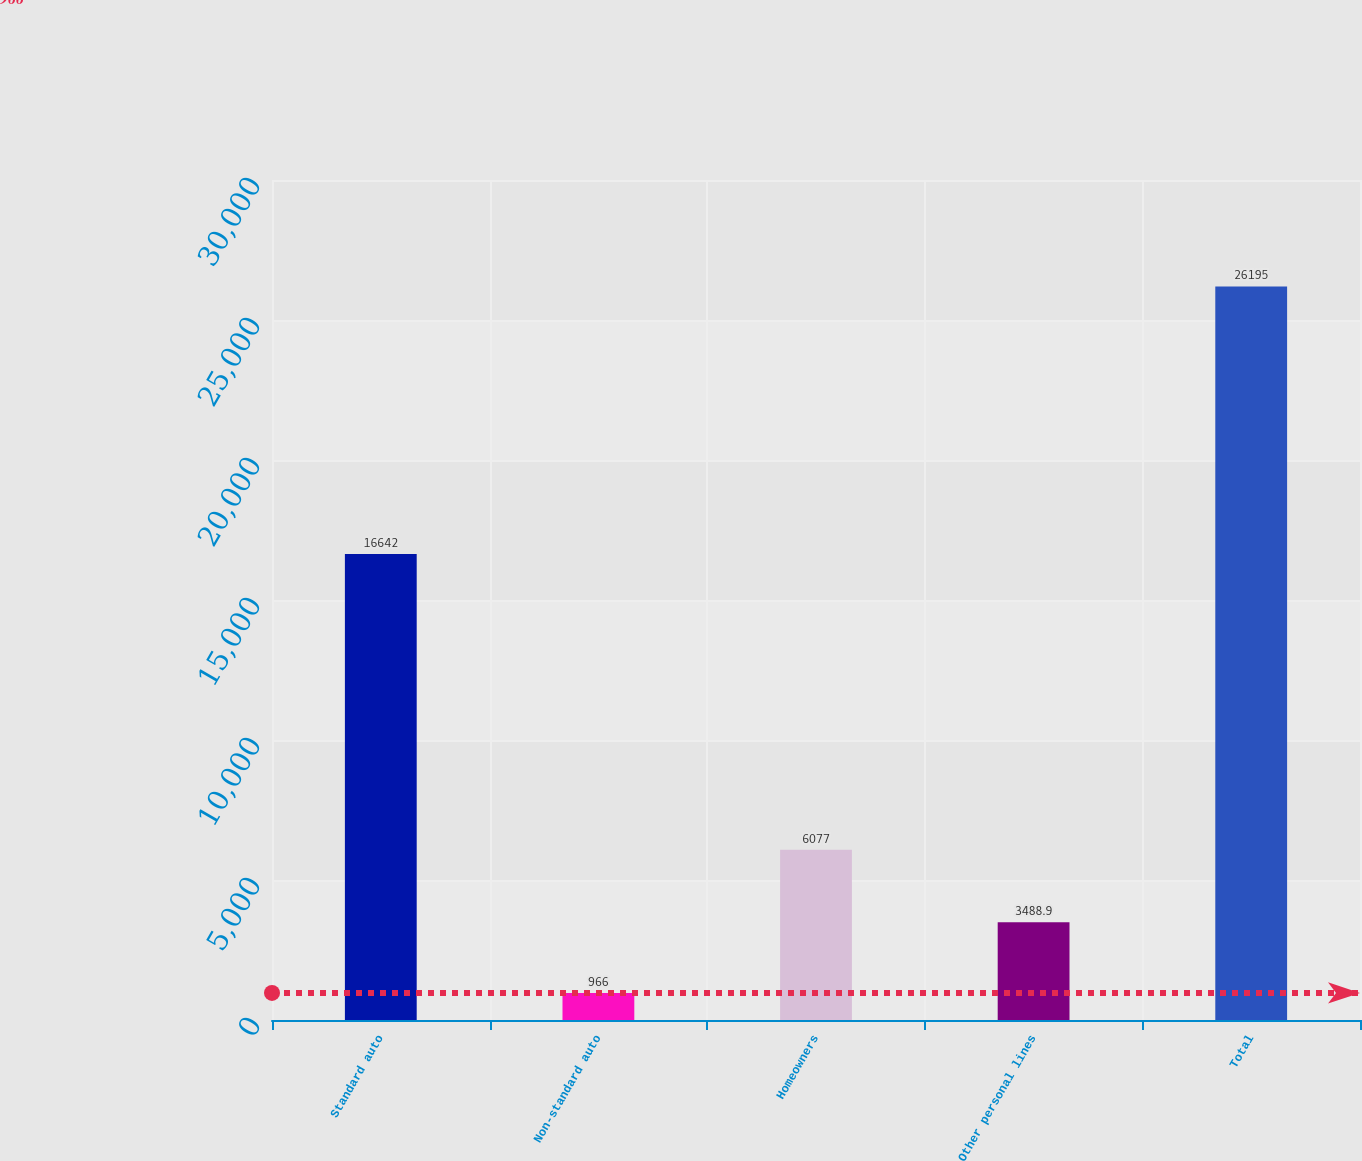Convert chart to OTSL. <chart><loc_0><loc_0><loc_500><loc_500><bar_chart><fcel>Standard auto<fcel>Non-standard auto<fcel>Homeowners<fcel>Other personal lines<fcel>Total<nl><fcel>16642<fcel>966<fcel>6077<fcel>3488.9<fcel>26195<nl></chart> 